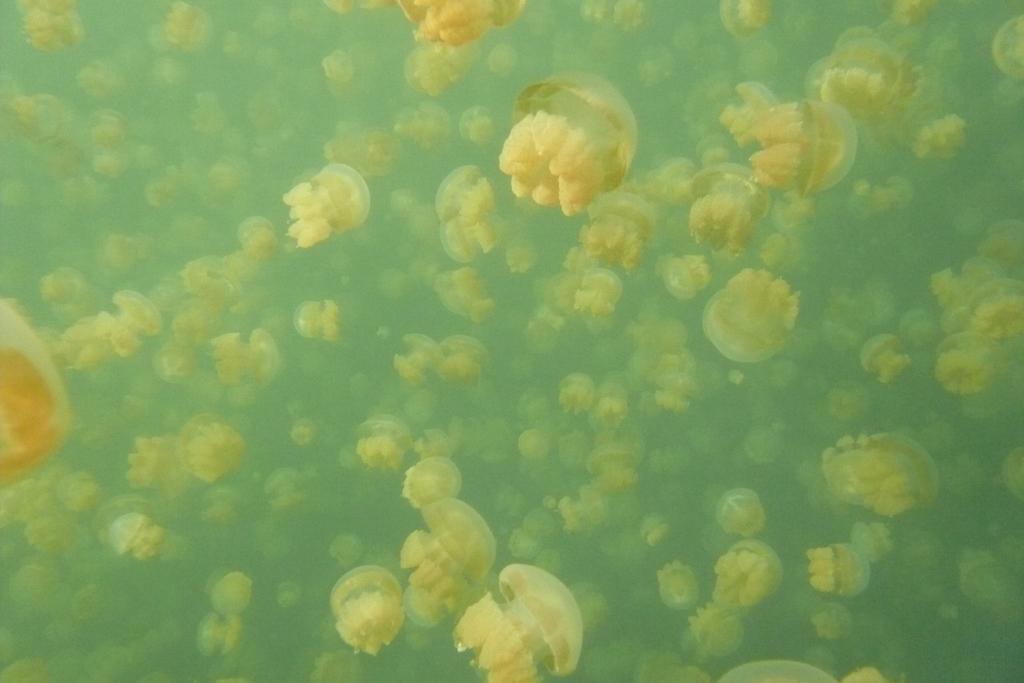Can you describe this image briefly? In this image we can see some jellyfish in the water. 